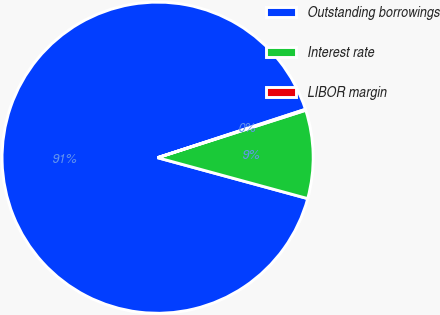Convert chart to OTSL. <chart><loc_0><loc_0><loc_500><loc_500><pie_chart><fcel>Outstanding borrowings<fcel>Interest rate<fcel>LIBOR margin<nl><fcel>90.73%<fcel>9.17%<fcel>0.1%<nl></chart> 